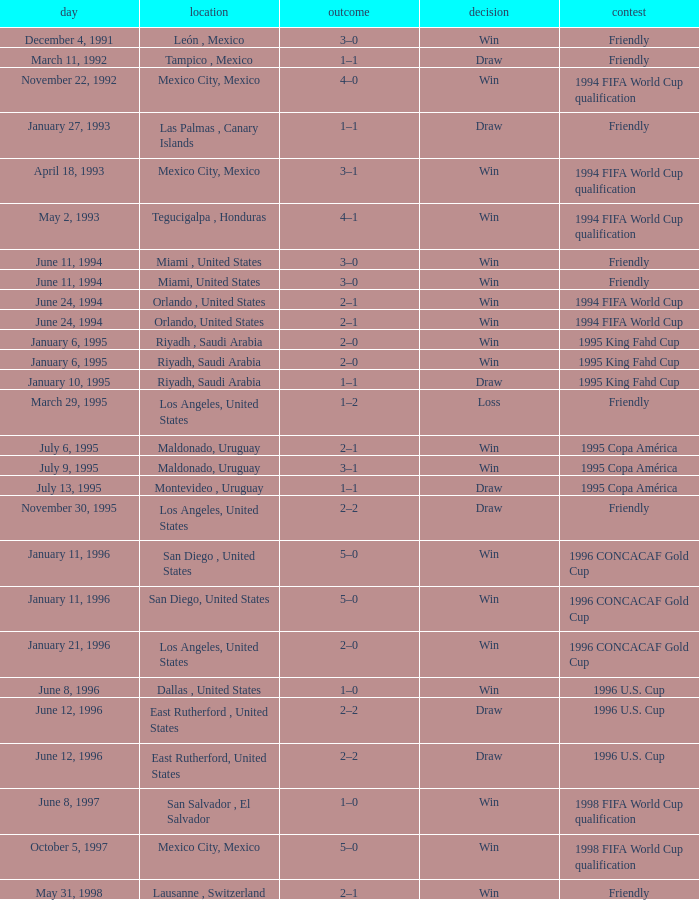What is Result, when Date is "June 11, 1994", and when Venue is "Miami, United States"? Win, Win. 